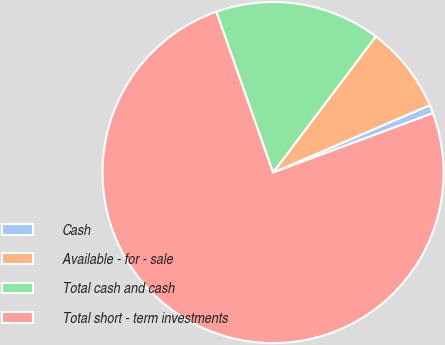Convert chart. <chart><loc_0><loc_0><loc_500><loc_500><pie_chart><fcel>Cash<fcel>Available - for - sale<fcel>Total cash and cash<fcel>Total short - term investments<nl><fcel>0.8%<fcel>8.25%<fcel>15.69%<fcel>75.26%<nl></chart> 